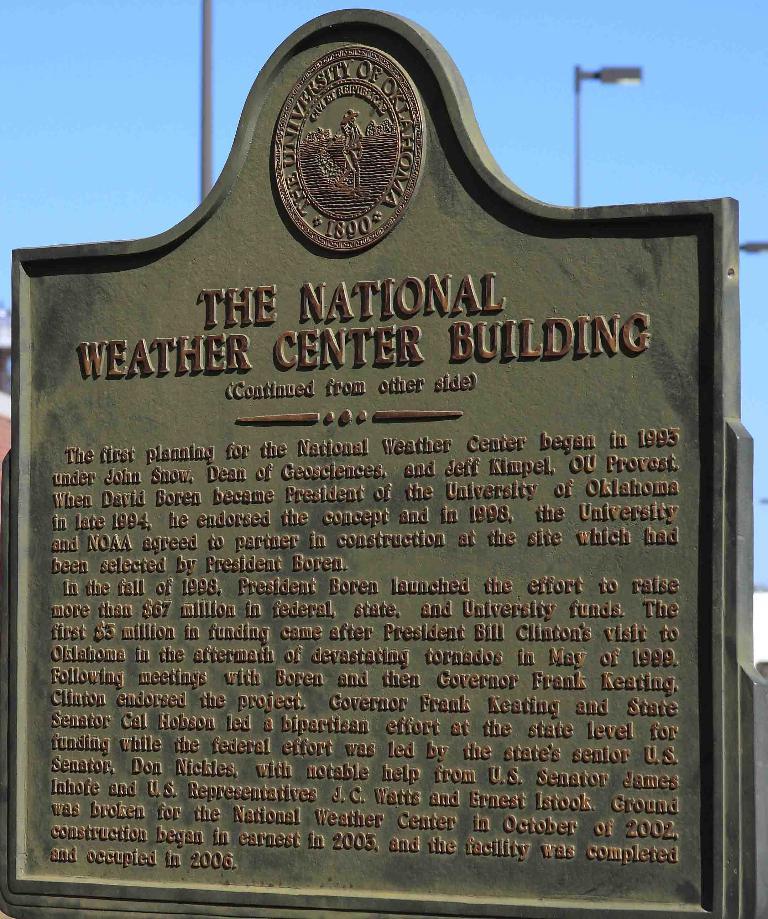When is the facility completed and occupied?
Ensure brevity in your answer.  2006. 